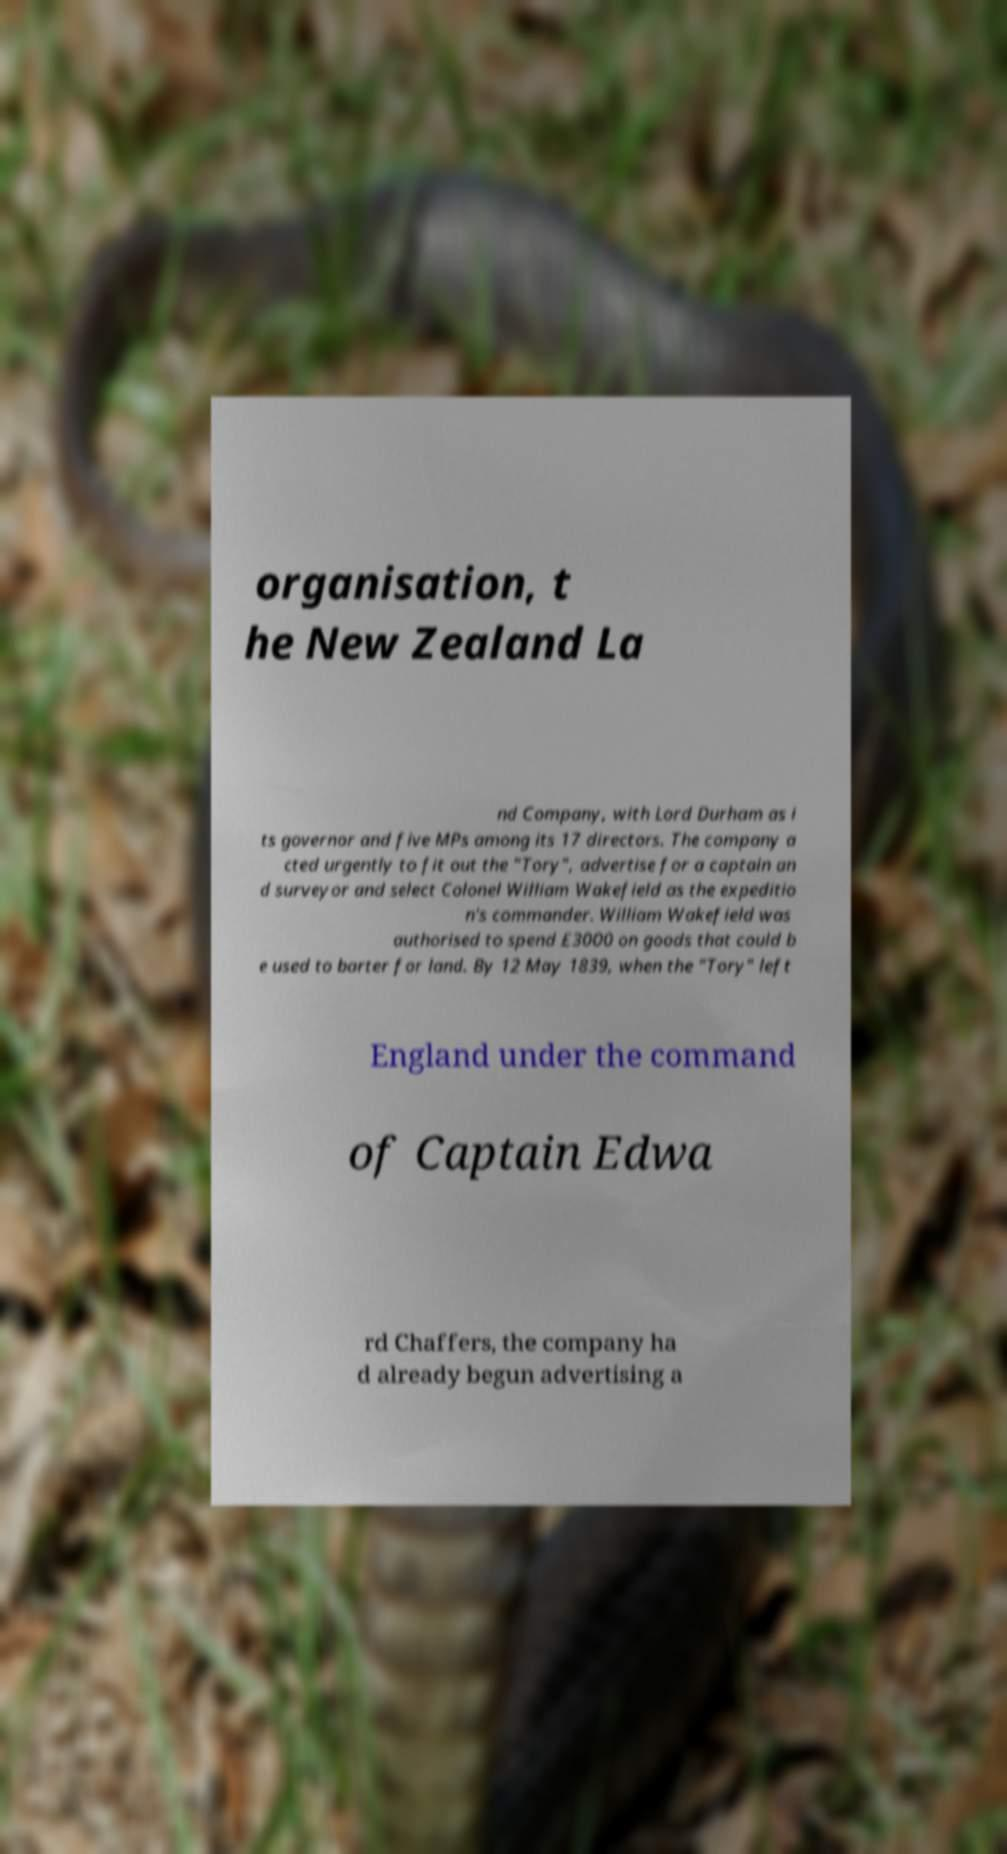Please read and relay the text visible in this image. What does it say? organisation, t he New Zealand La nd Company, with Lord Durham as i ts governor and five MPs among its 17 directors. The company a cted urgently to fit out the "Tory", advertise for a captain an d surveyor and select Colonel William Wakefield as the expeditio n's commander. William Wakefield was authorised to spend £3000 on goods that could b e used to barter for land. By 12 May 1839, when the "Tory" left England under the command of Captain Edwa rd Chaffers, the company ha d already begun advertising a 